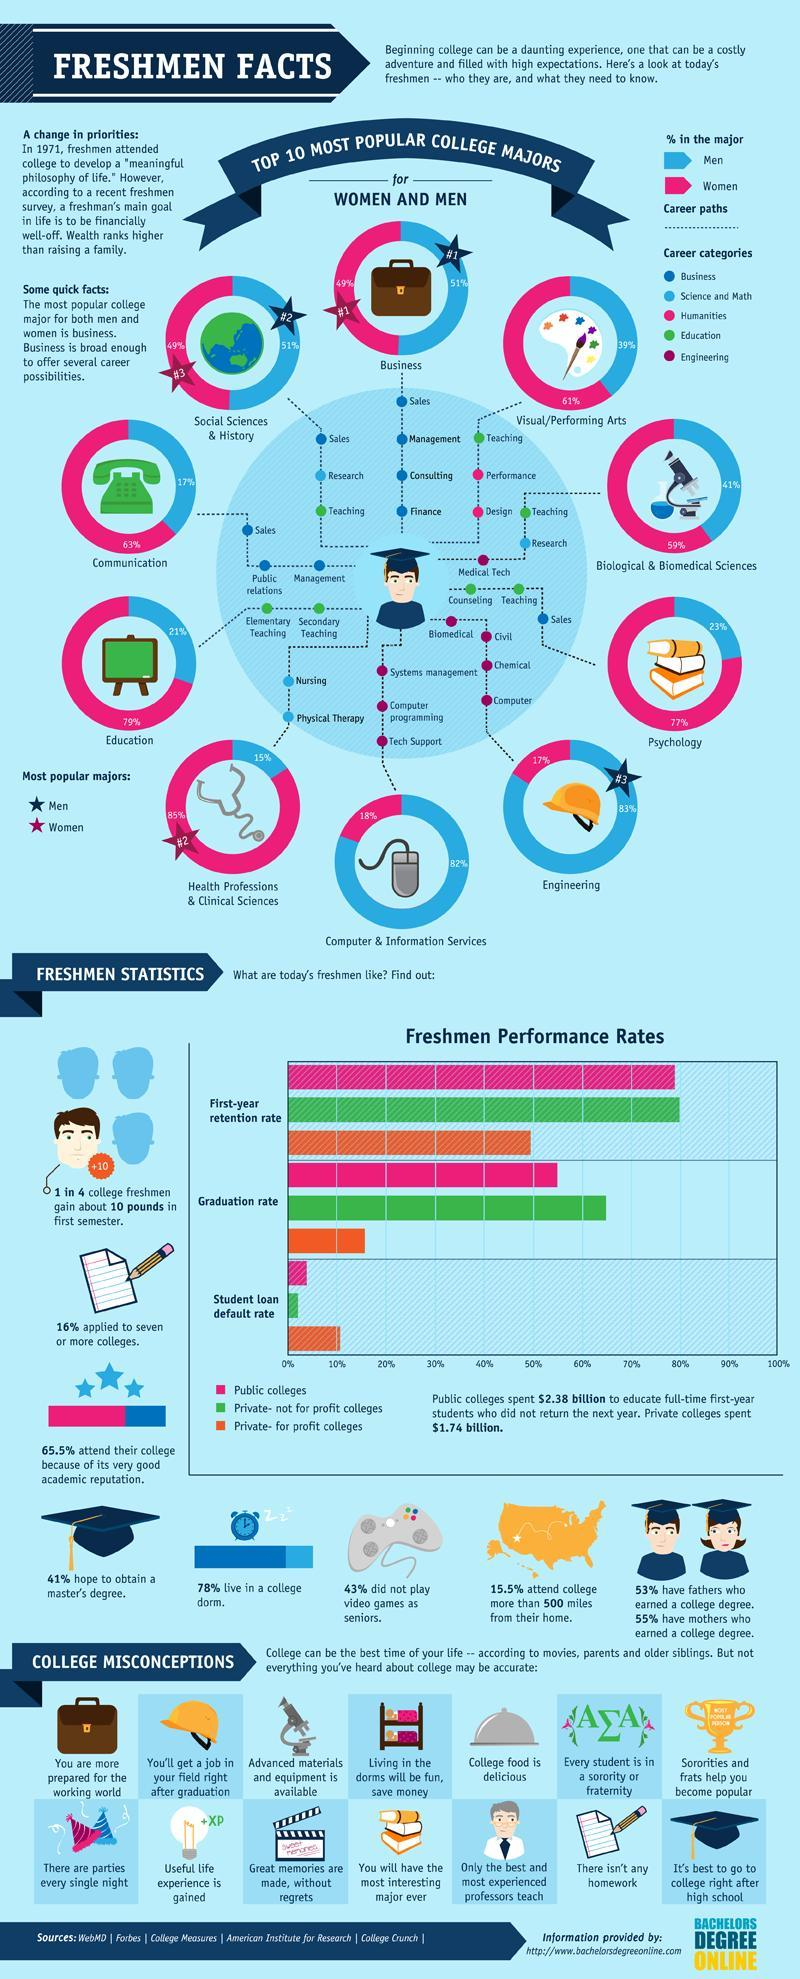Who has the highest share in Psychology-men, women?
Answer the question with a short phrase. women Who has the highest share in Computer & Information Services-women, men? men How many branches are there for Psychology? 3 How many streams are there for Engineering? 4 What percentage play video games as seniors? 57% 